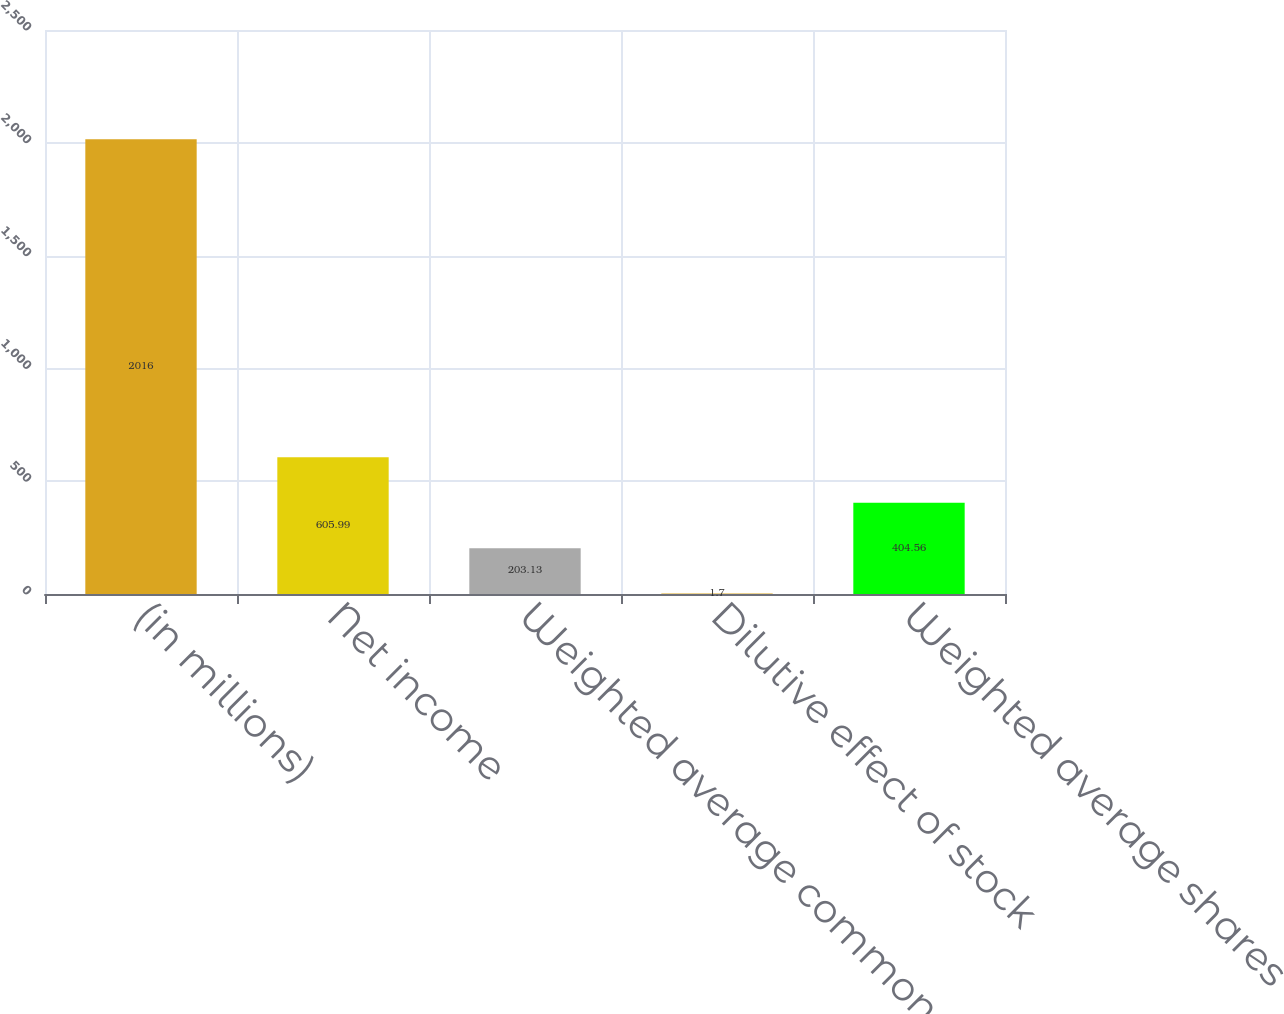Convert chart. <chart><loc_0><loc_0><loc_500><loc_500><bar_chart><fcel>(in millions)<fcel>Net income<fcel>Weighted average common shares<fcel>Dilutive effect of stock<fcel>Weighted average shares<nl><fcel>2016<fcel>605.99<fcel>203.13<fcel>1.7<fcel>404.56<nl></chart> 